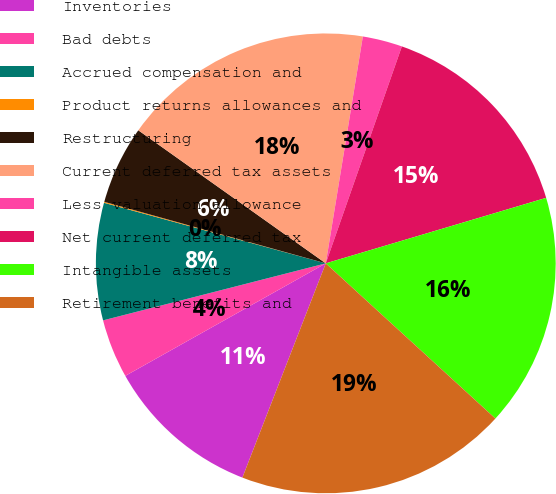Convert chart. <chart><loc_0><loc_0><loc_500><loc_500><pie_chart><fcel>Inventories<fcel>Bad debts<fcel>Accrued compensation and<fcel>Product returns allowances and<fcel>Restructuring<fcel>Current deferred tax assets<fcel>Less valuation allowance<fcel>Net current deferred tax<fcel>Intangible assets<fcel>Retirement benefits and<nl><fcel>10.95%<fcel>4.15%<fcel>8.23%<fcel>0.07%<fcel>5.51%<fcel>17.75%<fcel>2.79%<fcel>15.03%<fcel>16.39%<fcel>19.11%<nl></chart> 